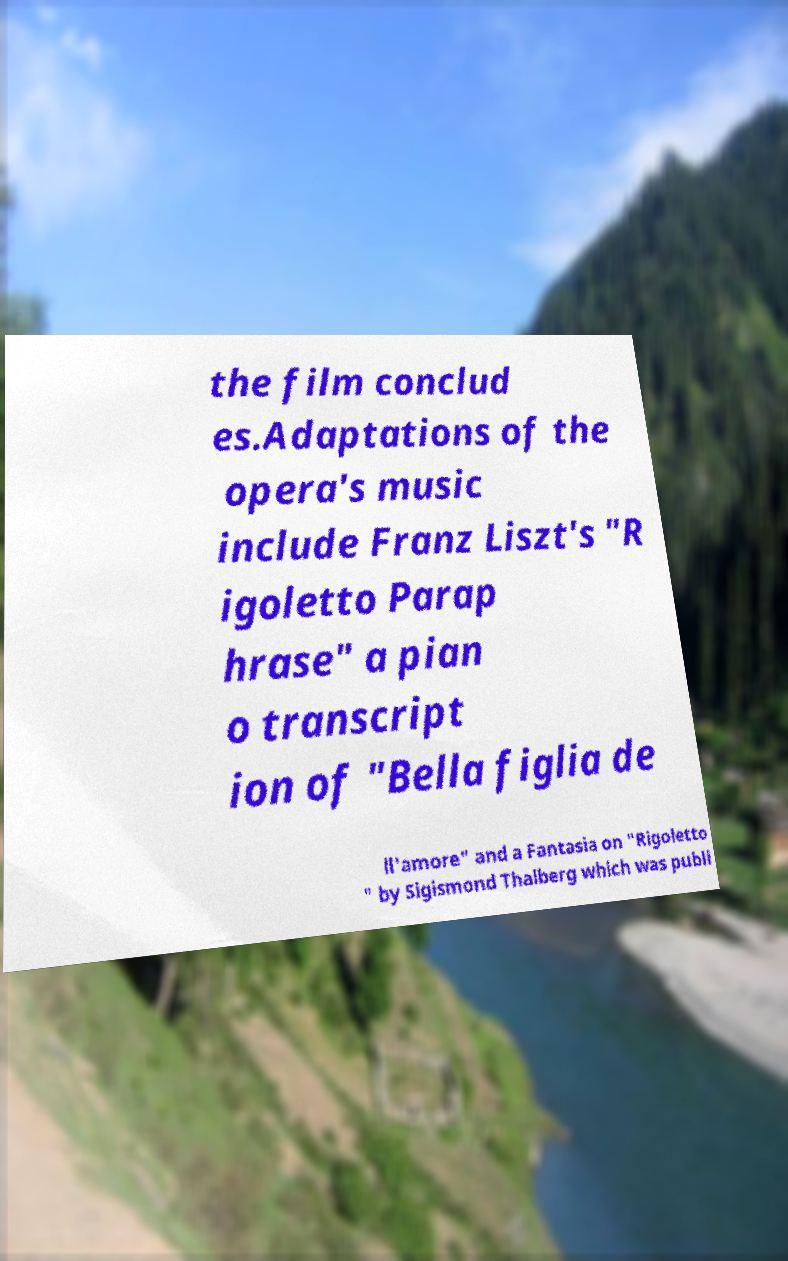Could you assist in decoding the text presented in this image and type it out clearly? the film conclud es.Adaptations of the opera's music include Franz Liszt's "R igoletto Parap hrase" a pian o transcript ion of "Bella figlia de ll'amore" and a Fantasia on "Rigoletto " by Sigismond Thalberg which was publi 